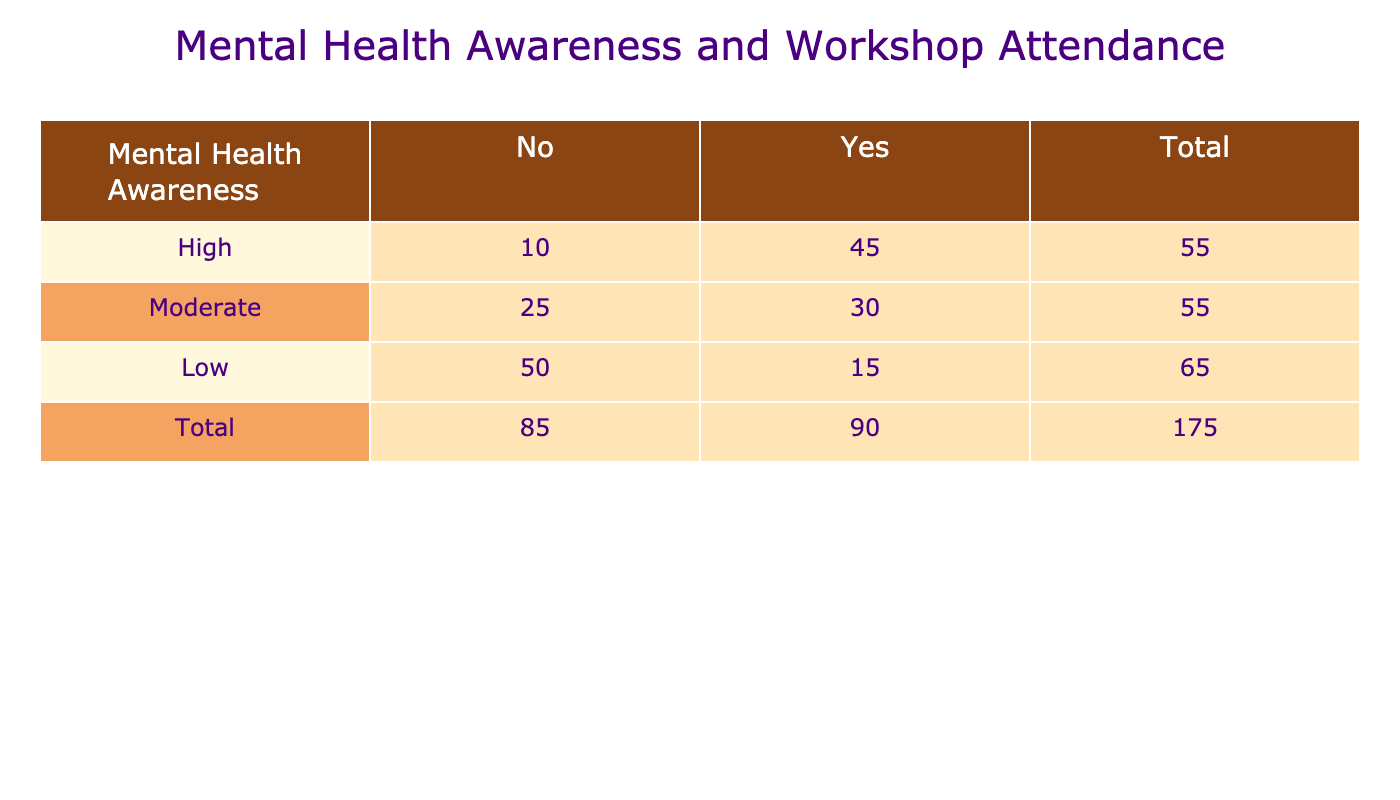What is the total number of students with low mental health awareness who attended a workshop? Looking at the "Low" category under "Attended_Workshop" and "Mental_Health_Awareness," the count is 15 students.
Answer: 15 What percentage of students with high mental health awareness attended the workshop? To find the percentage of students with high mental health awareness who attended the workshop, we take the number of students who attended (45) and divide it by the total number of students in the high awareness group (45 + 10 = 55). The calculation is (45/55) * 100% = approximately 81.82%.
Answer: 81.82% Did more students with moderate mental health awareness attend the workshop than those with low awareness? The count for students with moderate awareness attending is 30, whereas the count for low awareness attending is 15. Since 30 is greater than 15, the answer is yes.
Answer: Yes What is the total number of students who did not attend any workshops? The total number of students who did not attend workshops comprises those from "High" (10), "Moderate" (25), and "Low" (50) mental health awareness levels. Summing these (10 + 25 + 50) gives us 85 students.
Answer: 85 Which group had the highest total attendance at workshops? The total counts for each awareness level are: High (45), Moderate (30), Low (15). It’s clear that the high awareness group had the highest attendance because 45 is the maximum among the totals.
Answer: High What is the difference in attendance at workshops between students with moderate and high mental health awareness? The attendance for moderate awareness is 30 and for high awareness is 45. We subtract the moderate count from the high count: 45 - 30 = 15, indicating that 15 more students with high awareness attended than those with moderate awareness.
Answer: 15 How many total students were surveyed for this analysis? To determine the total number of students surveyed, we add up all the counts across the rows: (45 + 10 + 30 + 25 + 15 + 50) = 175 students in total.
Answer: 175 Is it true that more than half of students with moderate mental health awareness attended the workshops? For moderate awareness, 30 out of 55 total (30 attended + 25 did not) students attended workshops. To assess if this is more than half, we check if 30 > 27.5 (which is half of 55). Since 30 is greater than 27.5, it is true.
Answer: Yes 